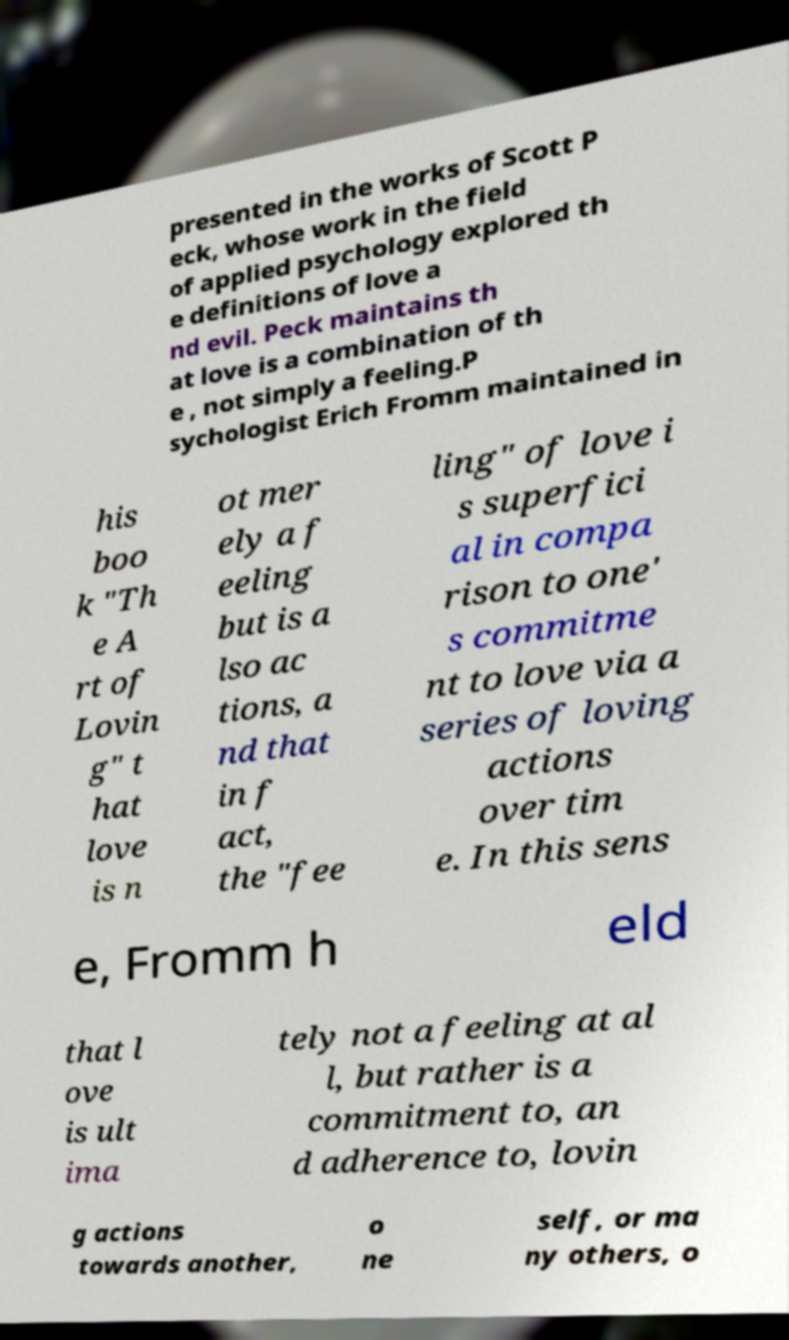I need the written content from this picture converted into text. Can you do that? presented in the works of Scott P eck, whose work in the field of applied psychology explored th e definitions of love a nd evil. Peck maintains th at love is a combination of th e , not simply a feeling.P sychologist Erich Fromm maintained in his boo k "Th e A rt of Lovin g" t hat love is n ot mer ely a f eeling but is a lso ac tions, a nd that in f act, the "fee ling" of love i s superfici al in compa rison to one' s commitme nt to love via a series of loving actions over tim e. In this sens e, Fromm h eld that l ove is ult ima tely not a feeling at al l, but rather is a commitment to, an d adherence to, lovin g actions towards another, o ne self, or ma ny others, o 